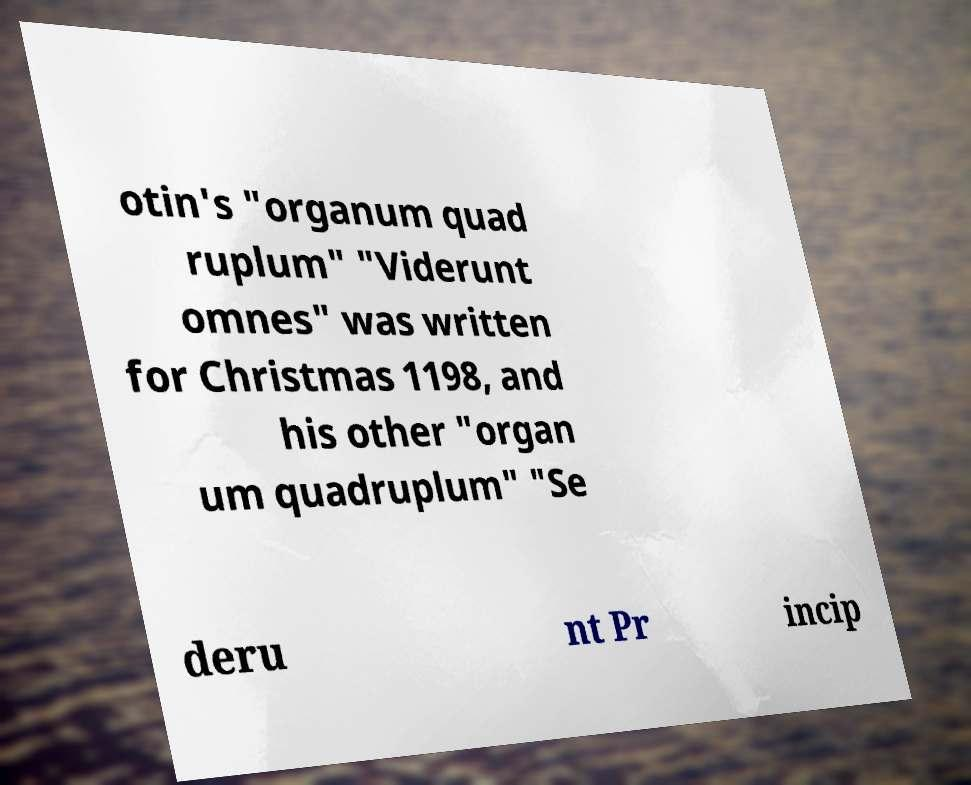Can you accurately transcribe the text from the provided image for me? otin's "organum quad ruplum" "Viderunt omnes" was written for Christmas 1198, and his other "organ um quadruplum" "Se deru nt Pr incip 